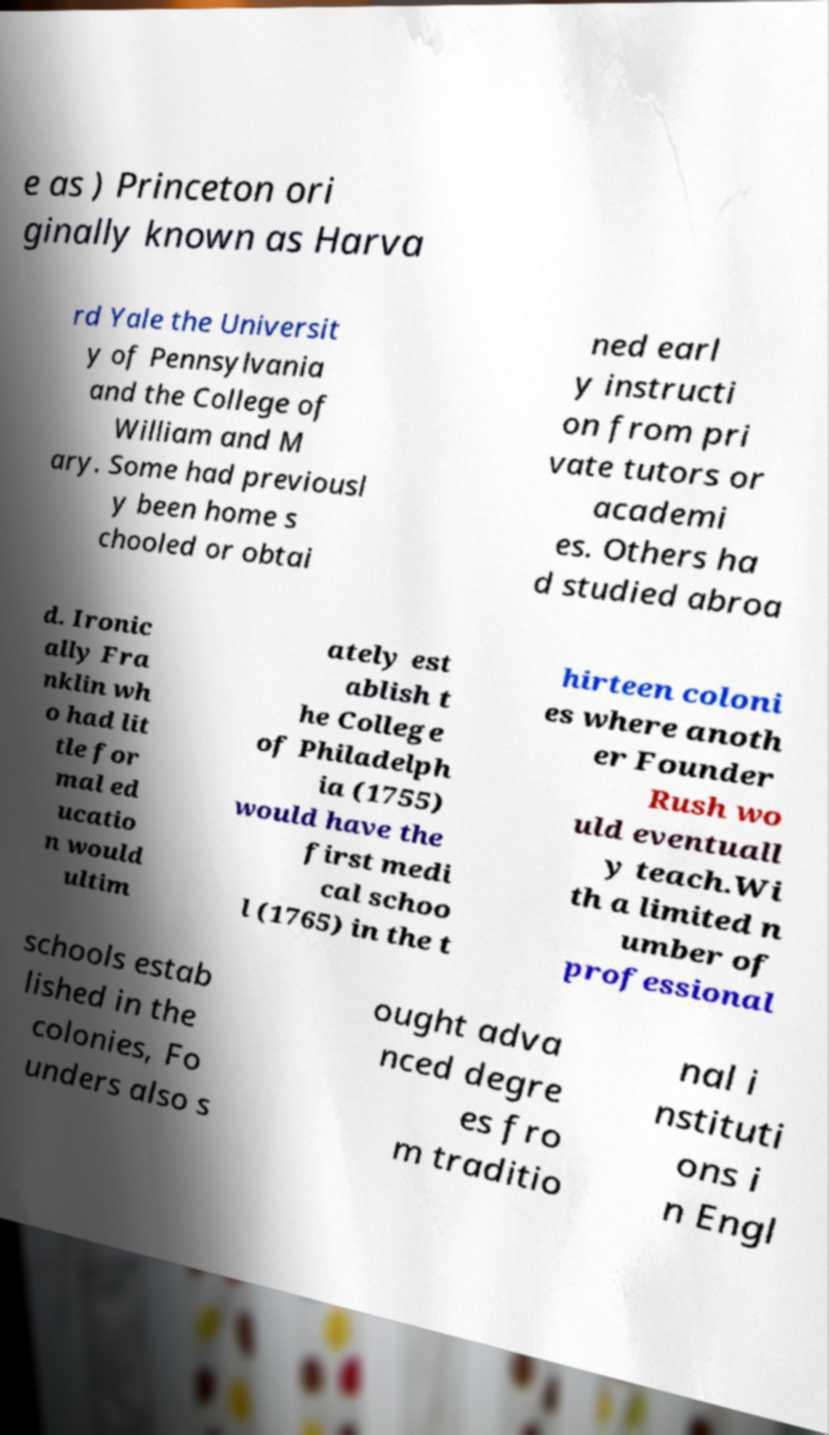Can you accurately transcribe the text from the provided image for me? e as ) Princeton ori ginally known as Harva rd Yale the Universit y of Pennsylvania and the College of William and M ary. Some had previousl y been home s chooled or obtai ned earl y instructi on from pri vate tutors or academi es. Others ha d studied abroa d. Ironic ally Fra nklin wh o had lit tle for mal ed ucatio n would ultim ately est ablish t he College of Philadelph ia (1755) would have the first medi cal schoo l (1765) in the t hirteen coloni es where anoth er Founder Rush wo uld eventuall y teach.Wi th a limited n umber of professional schools estab lished in the colonies, Fo unders also s ought adva nced degre es fro m traditio nal i nstituti ons i n Engl 